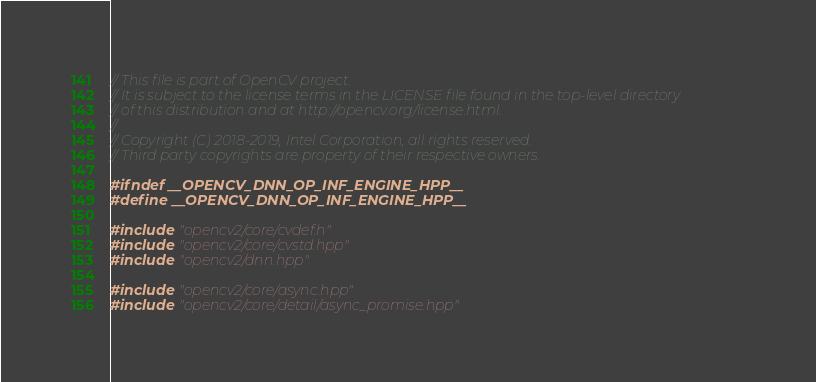<code> <loc_0><loc_0><loc_500><loc_500><_C++_>// This file is part of OpenCV project.
// It is subject to the license terms in the LICENSE file found in the top-level directory
// of this distribution and at http://opencv.org/license.html.
//
// Copyright (C) 2018-2019, Intel Corporation, all rights reserved.
// Third party copyrights are property of their respective owners.

#ifndef __OPENCV_DNN_OP_INF_ENGINE_HPP__
#define __OPENCV_DNN_OP_INF_ENGINE_HPP__

#include "opencv2/core/cvdef.h"
#include "opencv2/core/cvstd.hpp"
#include "opencv2/dnn.hpp"

#include "opencv2/core/async.hpp"
#include "opencv2/core/detail/async_promise.hpp"
</code> 